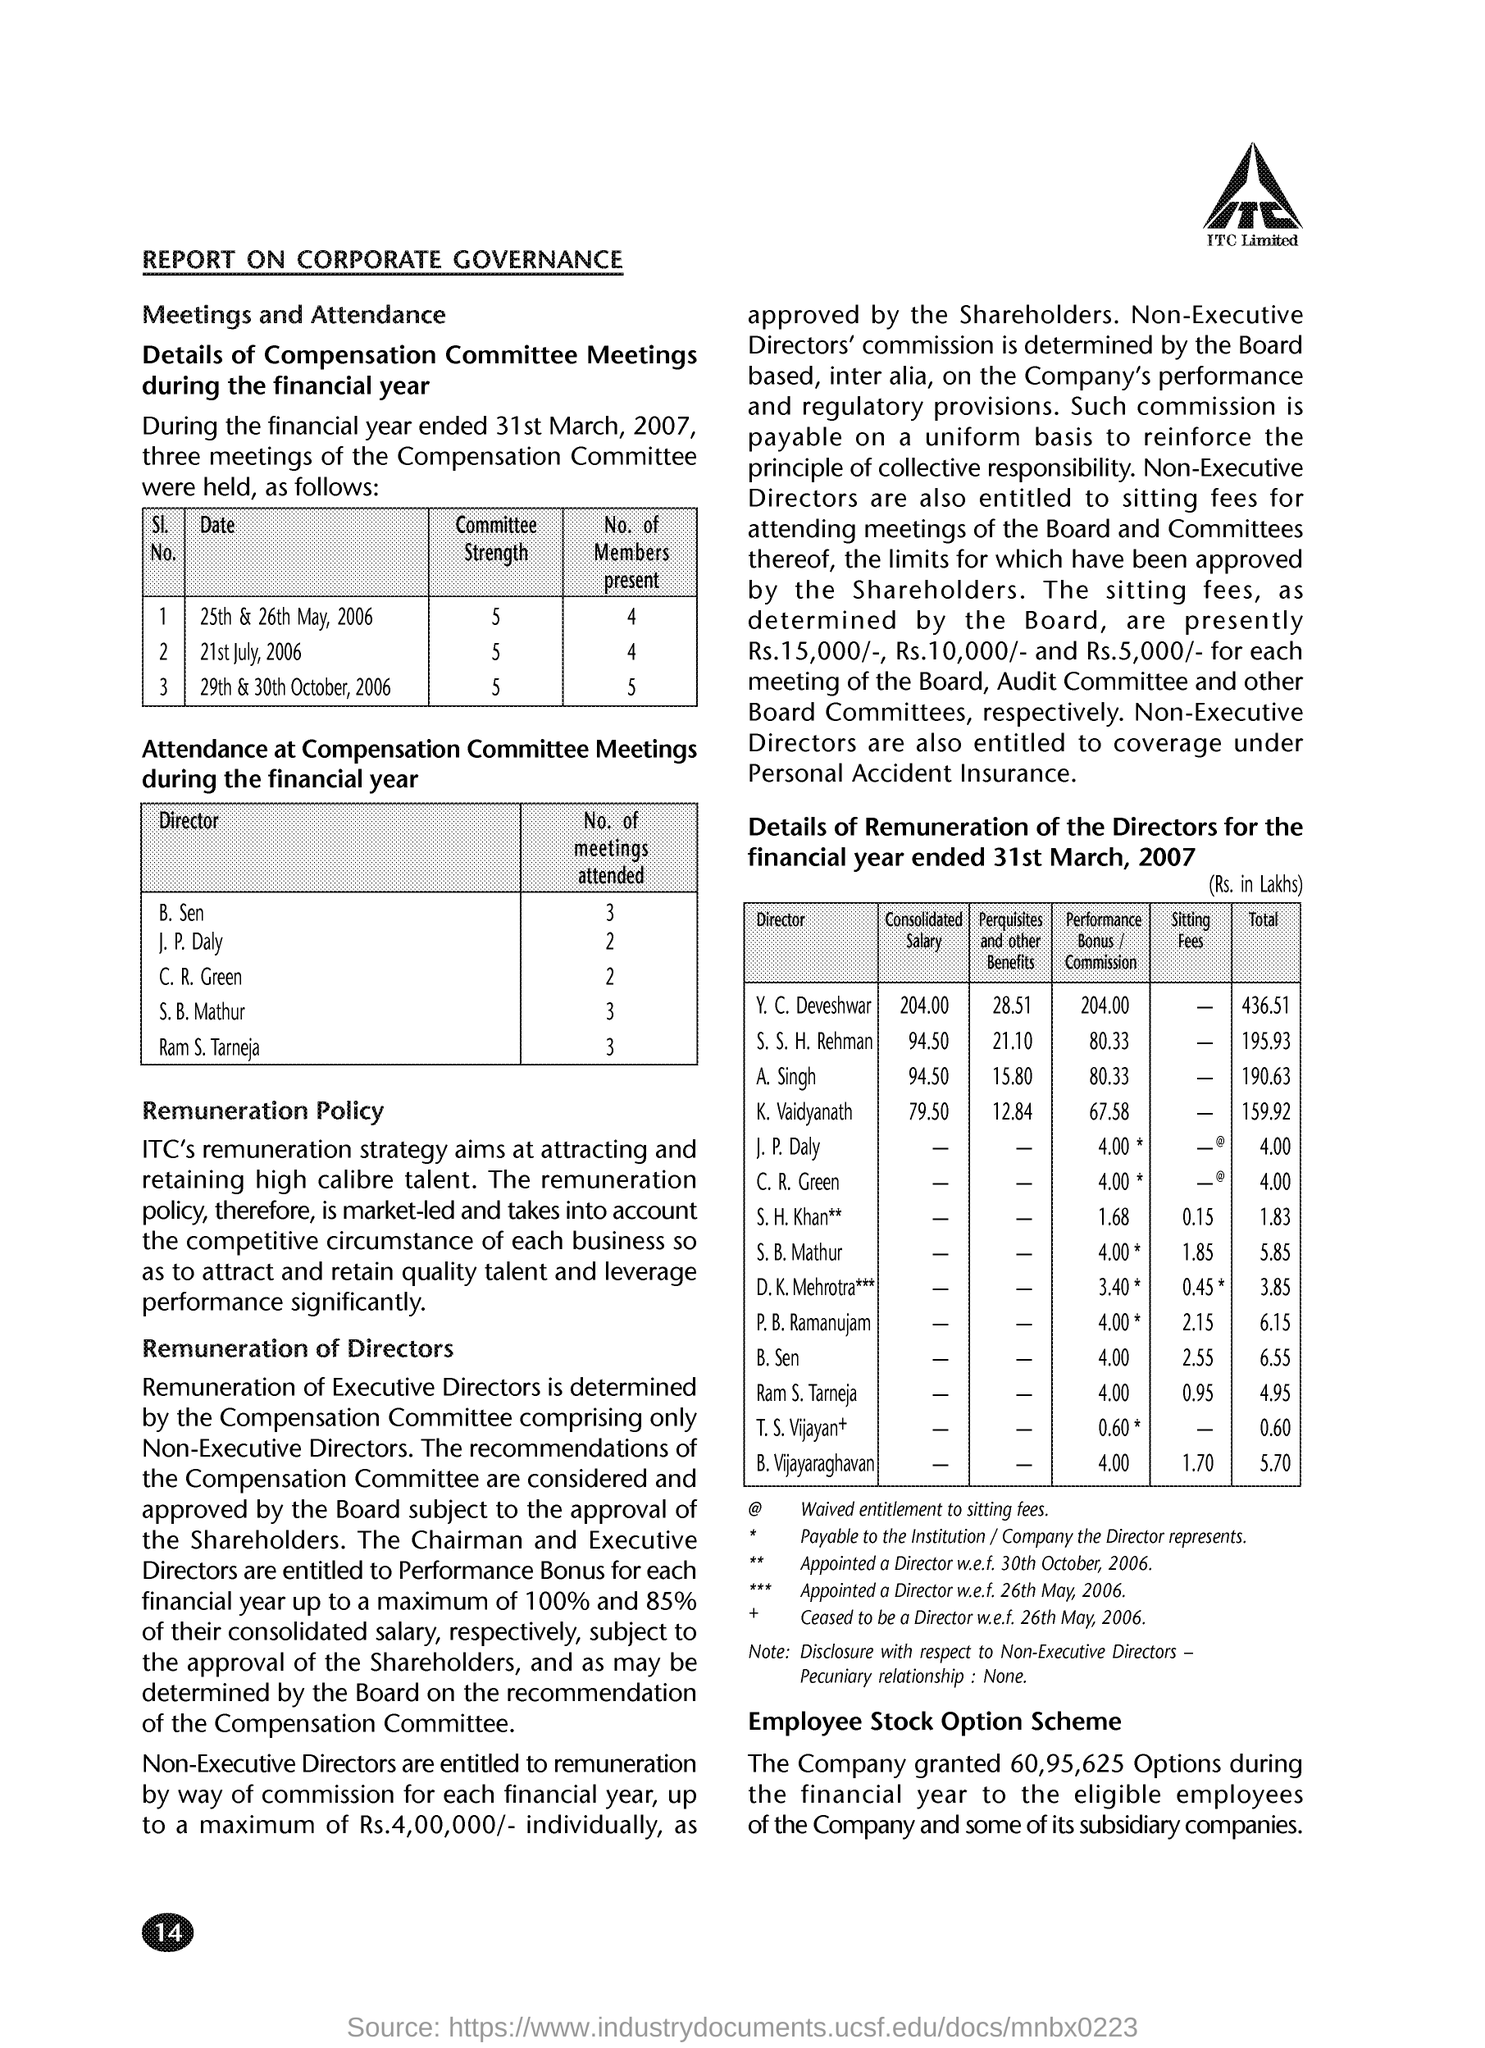Highlight a few significant elements in this photo. On July 21, 2006, the committee strength was 5. On October 29th and 30th of the year 2006, the committee strength was X. The director, C.R. Green, attended two meetings. The director, B.Sen, attended 3 meetings. 